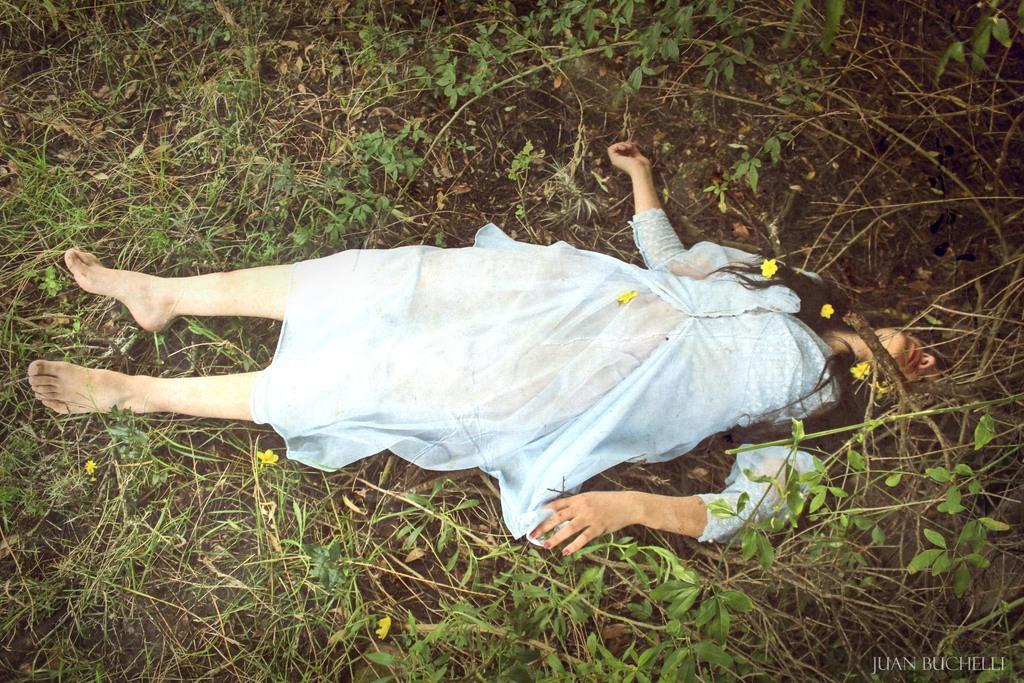Who is present in the image? There is a woman in the image. What is the woman doing in the image? The woman is lying on the ground. What type of terrain is visible in the image? There is mud in the image. What type of vegetation can be seen in the image? There are flowers and plants in the image. What type of church can be seen in the image? There is no church present in the image. How many trees are visible in the image? There are no trees visible in the image. 